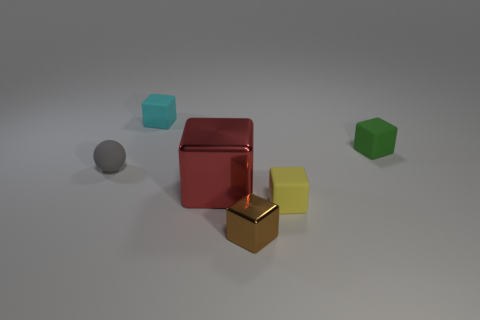There is a matte thing behind the green cube; how many tiny rubber cubes are to the right of it?
Your answer should be very brief. 2. What number of other things are there of the same color as the small matte sphere?
Ensure brevity in your answer.  0. There is a matte thing on the left side of the matte cube to the left of the yellow thing; what is its color?
Offer a very short reply. Gray. Are there any big metal cylinders of the same color as the big metal object?
Give a very brief answer. No. How many shiny objects are either gray balls or green objects?
Offer a terse response. 0. Are there any big gray blocks that have the same material as the brown object?
Make the answer very short. No. What number of objects are both in front of the red metal thing and on the left side of the tiny yellow block?
Give a very brief answer. 1. Is the number of brown shiny blocks behind the tiny green rubber block less than the number of small yellow rubber blocks on the left side of the large thing?
Make the answer very short. No. Does the yellow object have the same shape as the gray rubber thing?
Provide a succinct answer. No. How many other objects are the same size as the gray rubber object?
Provide a succinct answer. 4. 